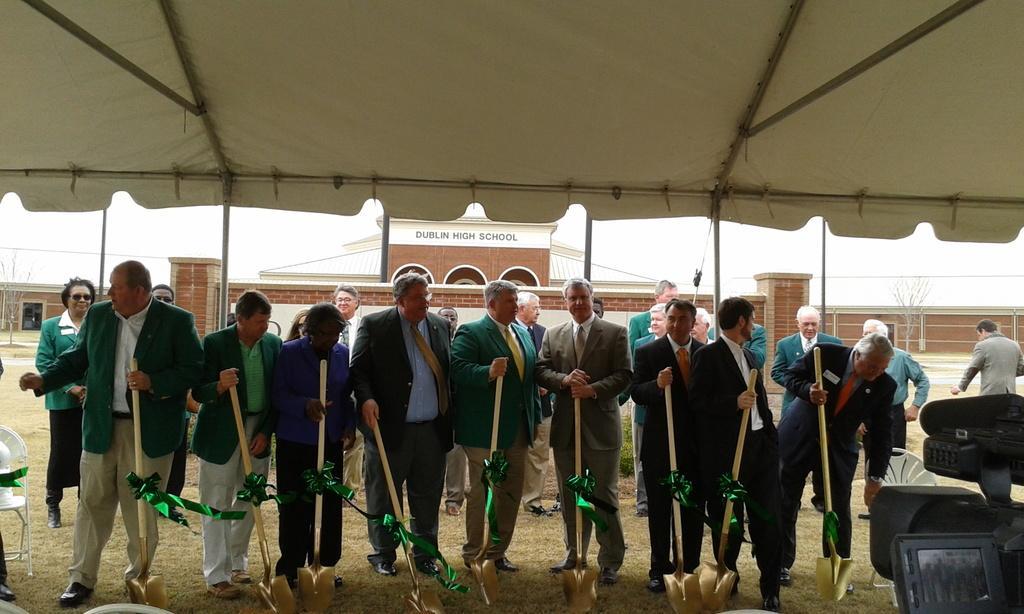Can you describe this image briefly? In this image there are a group of people standing, and they are holding some sticks. And in the background there is a building, trees and in the foreground there is a tent. And on the right side and left side there are some chairs and a camera. At the bottom there is grass. 